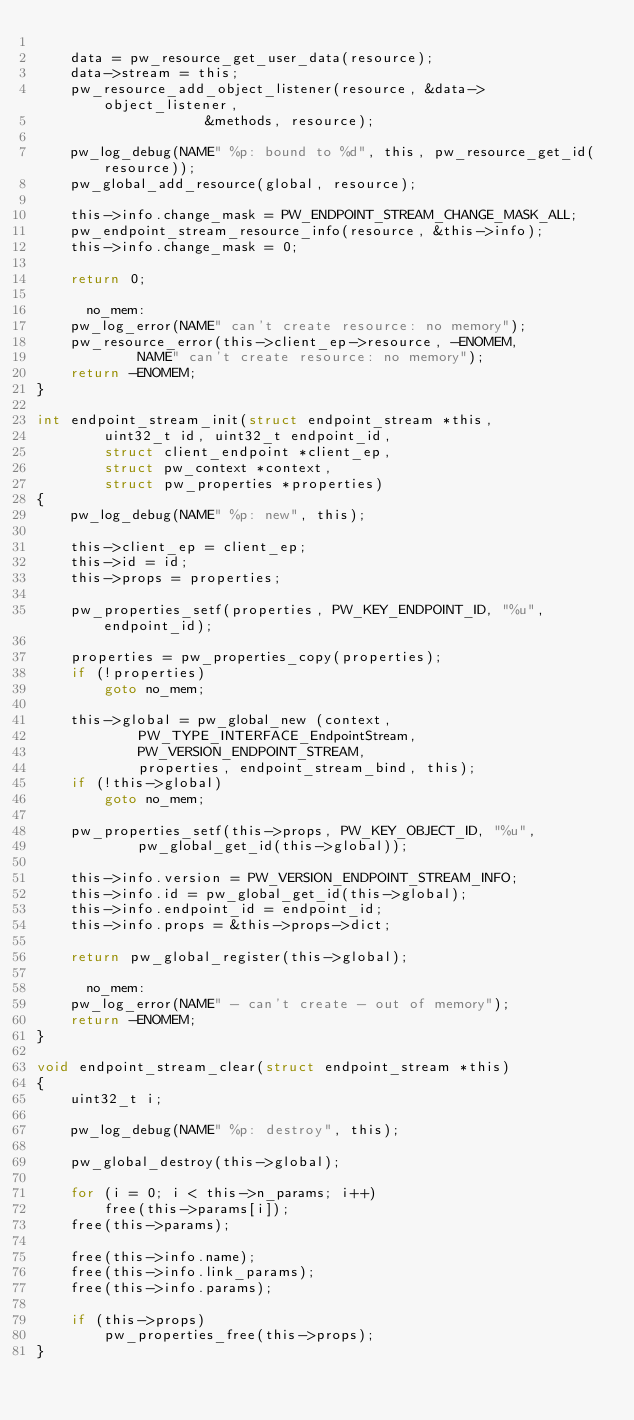<code> <loc_0><loc_0><loc_500><loc_500><_C_>
	data = pw_resource_get_user_data(resource);
	data->stream = this;
	pw_resource_add_object_listener(resource, &data->object_listener,
					&methods, resource);

	pw_log_debug(NAME" %p: bound to %d", this, pw_resource_get_id(resource));
	pw_global_add_resource(global, resource);

	this->info.change_mask = PW_ENDPOINT_STREAM_CHANGE_MASK_ALL;
	pw_endpoint_stream_resource_info(resource, &this->info);
	this->info.change_mask = 0;

	return 0;

      no_mem:
	pw_log_error(NAME" can't create resource: no memory");
	pw_resource_error(this->client_ep->resource, -ENOMEM,
			NAME" can't create resource: no memory");
	return -ENOMEM;
}

int endpoint_stream_init(struct endpoint_stream *this,
		uint32_t id, uint32_t endpoint_id,
		struct client_endpoint *client_ep,
		struct pw_context *context,
		struct pw_properties *properties)
{
	pw_log_debug(NAME" %p: new", this);

	this->client_ep = client_ep;
	this->id = id;
	this->props = properties;

	pw_properties_setf(properties, PW_KEY_ENDPOINT_ID, "%u", endpoint_id);

	properties = pw_properties_copy(properties);
	if (!properties)
		goto no_mem;

	this->global = pw_global_new (context,
			PW_TYPE_INTERFACE_EndpointStream,
			PW_VERSION_ENDPOINT_STREAM,
			properties, endpoint_stream_bind, this);
	if (!this->global)
		goto no_mem;

	pw_properties_setf(this->props, PW_KEY_OBJECT_ID, "%u",
			pw_global_get_id(this->global));

	this->info.version = PW_VERSION_ENDPOINT_STREAM_INFO;
	this->info.id = pw_global_get_id(this->global);
	this->info.endpoint_id = endpoint_id;
	this->info.props = &this->props->dict;

	return pw_global_register(this->global);

      no_mem:
	pw_log_error(NAME" - can't create - out of memory");
	return -ENOMEM;
}

void endpoint_stream_clear(struct endpoint_stream *this)
{
	uint32_t i;

	pw_log_debug(NAME" %p: destroy", this);

	pw_global_destroy(this->global);

	for (i = 0; i < this->n_params; i++)
		free(this->params[i]);
	free(this->params);

	free(this->info.name);
	free(this->info.link_params);
	free(this->info.params);

	if (this->props)
		pw_properties_free(this->props);
}
</code> 